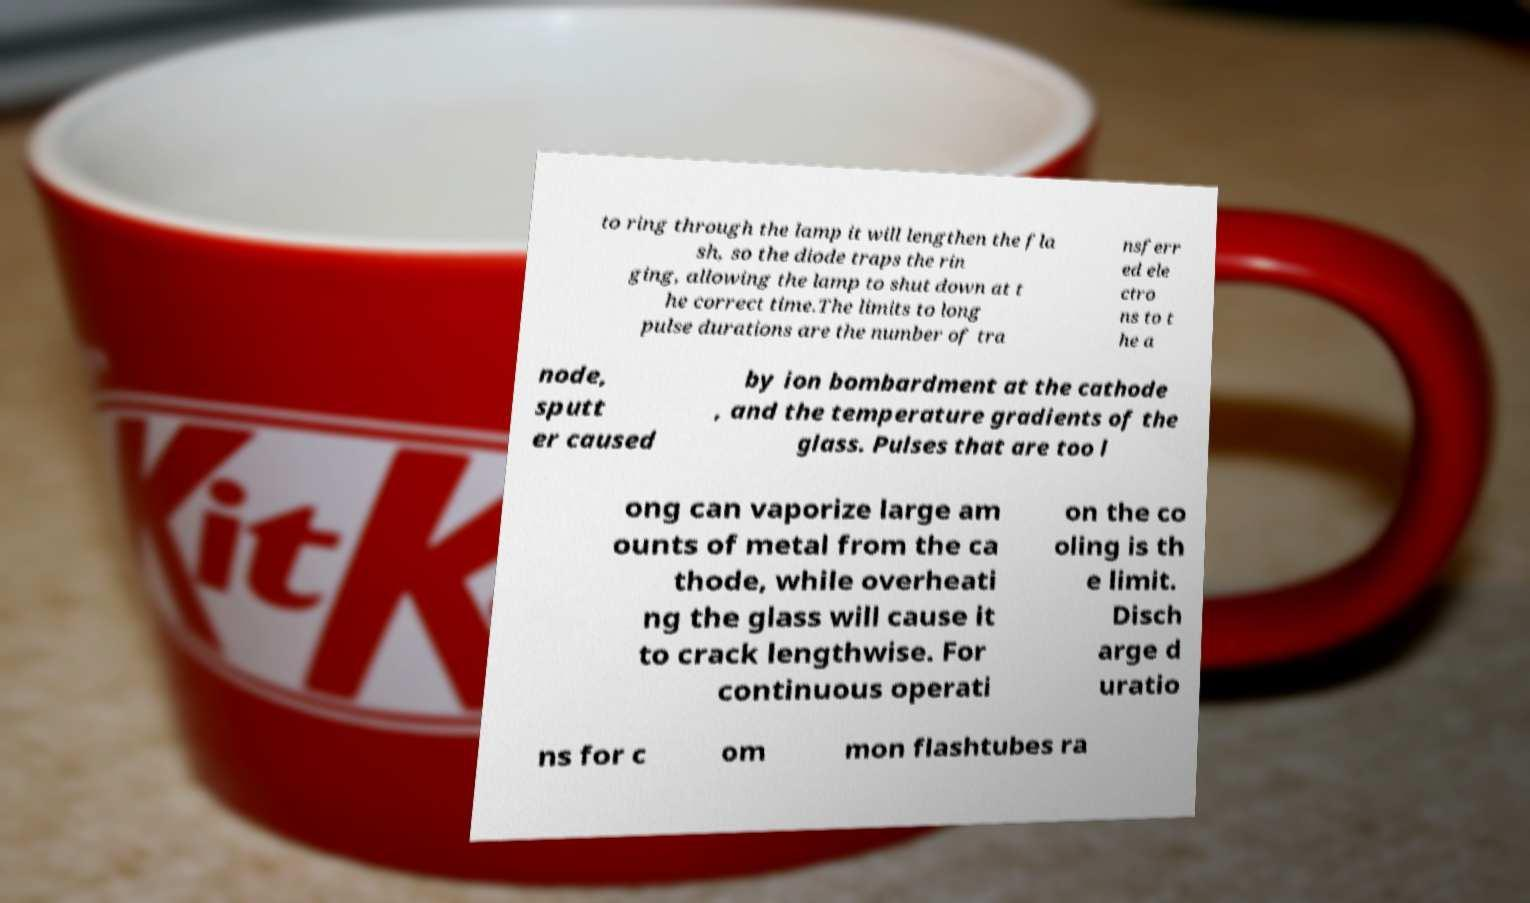Can you read and provide the text displayed in the image?This photo seems to have some interesting text. Can you extract and type it out for me? to ring through the lamp it will lengthen the fla sh, so the diode traps the rin ging, allowing the lamp to shut down at t he correct time.The limits to long pulse durations are the number of tra nsferr ed ele ctro ns to t he a node, sputt er caused by ion bombardment at the cathode , and the temperature gradients of the glass. Pulses that are too l ong can vaporize large am ounts of metal from the ca thode, while overheati ng the glass will cause it to crack lengthwise. For continuous operati on the co oling is th e limit. Disch arge d uratio ns for c om mon flashtubes ra 